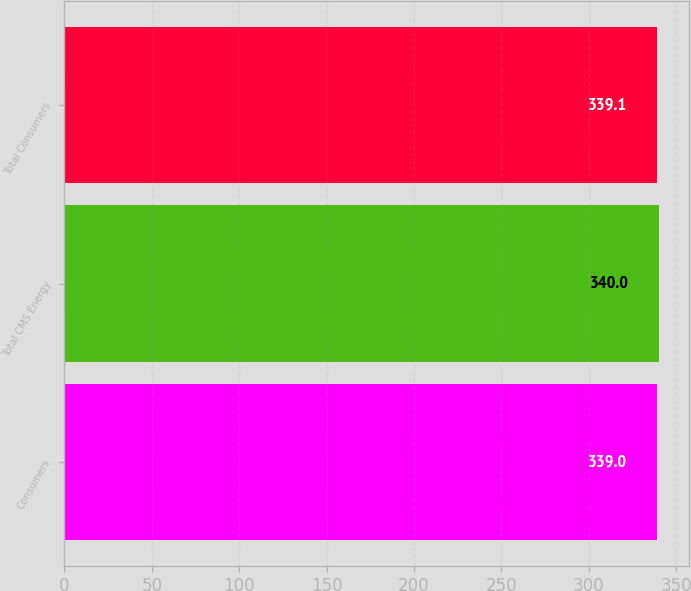Convert chart to OTSL. <chart><loc_0><loc_0><loc_500><loc_500><bar_chart><fcel>Consumers<fcel>Total CMS Energy<fcel>Total Consumers<nl><fcel>339<fcel>340<fcel>339.1<nl></chart> 